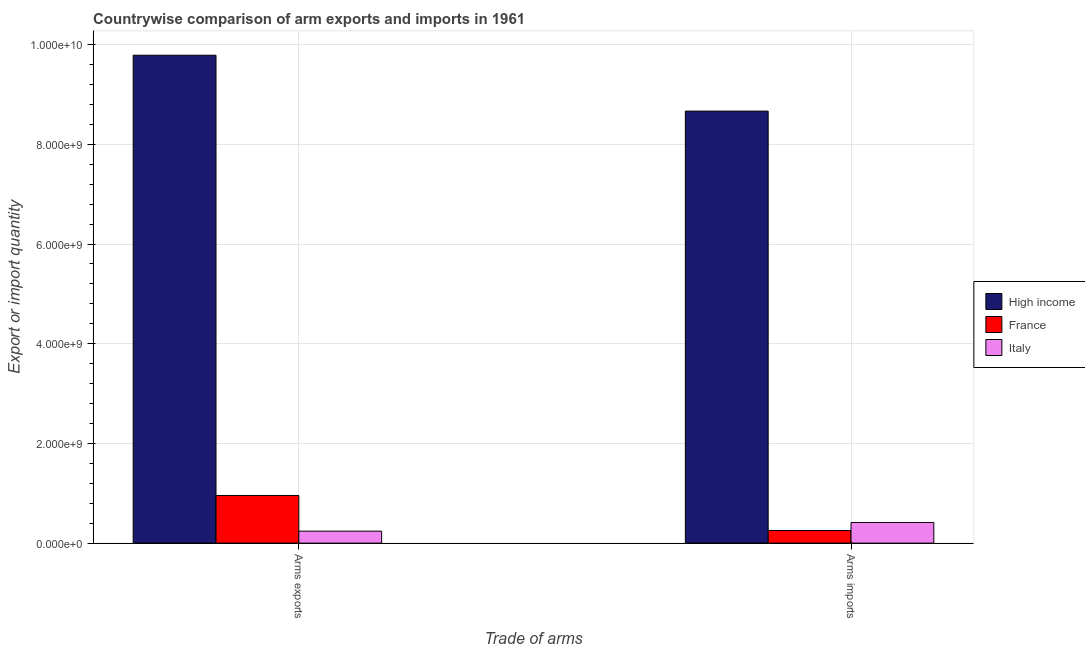How many different coloured bars are there?
Provide a short and direct response. 3. How many groups of bars are there?
Your response must be concise. 2. Are the number of bars per tick equal to the number of legend labels?
Provide a succinct answer. Yes. How many bars are there on the 2nd tick from the left?
Offer a terse response. 3. How many bars are there on the 1st tick from the right?
Give a very brief answer. 3. What is the label of the 2nd group of bars from the left?
Offer a very short reply. Arms imports. What is the arms exports in High income?
Make the answer very short. 9.79e+09. Across all countries, what is the maximum arms exports?
Your answer should be compact. 9.79e+09. Across all countries, what is the minimum arms imports?
Give a very brief answer. 2.53e+08. In which country was the arms exports maximum?
Give a very brief answer. High income. What is the total arms exports in the graph?
Your answer should be very brief. 1.10e+1. What is the difference between the arms exports in High income and that in Italy?
Provide a succinct answer. 9.55e+09. What is the difference between the arms exports in High income and the arms imports in Italy?
Ensure brevity in your answer.  9.37e+09. What is the average arms imports per country?
Offer a terse response. 3.11e+09. What is the difference between the arms imports and arms exports in Italy?
Provide a short and direct response. 1.74e+08. In how many countries, is the arms imports greater than 6400000000 ?
Offer a terse response. 1. What is the ratio of the arms exports in Italy to that in High income?
Give a very brief answer. 0.02. Is the arms imports in Italy less than that in High income?
Your answer should be compact. Yes. What does the 1st bar from the left in Arms exports represents?
Your answer should be compact. High income. What does the 2nd bar from the right in Arms imports represents?
Your answer should be compact. France. Are all the bars in the graph horizontal?
Ensure brevity in your answer.  No. How many countries are there in the graph?
Make the answer very short. 3. What is the difference between two consecutive major ticks on the Y-axis?
Your answer should be very brief. 2.00e+09. Does the graph contain grids?
Keep it short and to the point. Yes. What is the title of the graph?
Give a very brief answer. Countrywise comparison of arm exports and imports in 1961. Does "Bosnia and Herzegovina" appear as one of the legend labels in the graph?
Your response must be concise. No. What is the label or title of the X-axis?
Your response must be concise. Trade of arms. What is the label or title of the Y-axis?
Your answer should be very brief. Export or import quantity. What is the Export or import quantity in High income in Arms exports?
Offer a terse response. 9.79e+09. What is the Export or import quantity in France in Arms exports?
Make the answer very short. 9.56e+08. What is the Export or import quantity in Italy in Arms exports?
Your answer should be compact. 2.40e+08. What is the Export or import quantity in High income in Arms imports?
Your response must be concise. 8.67e+09. What is the Export or import quantity in France in Arms imports?
Your answer should be compact. 2.53e+08. What is the Export or import quantity in Italy in Arms imports?
Make the answer very short. 4.14e+08. Across all Trade of arms, what is the maximum Export or import quantity of High income?
Your answer should be compact. 9.79e+09. Across all Trade of arms, what is the maximum Export or import quantity of France?
Ensure brevity in your answer.  9.56e+08. Across all Trade of arms, what is the maximum Export or import quantity in Italy?
Your answer should be compact. 4.14e+08. Across all Trade of arms, what is the minimum Export or import quantity of High income?
Your answer should be compact. 8.67e+09. Across all Trade of arms, what is the minimum Export or import quantity of France?
Provide a succinct answer. 2.53e+08. Across all Trade of arms, what is the minimum Export or import quantity of Italy?
Keep it short and to the point. 2.40e+08. What is the total Export or import quantity in High income in the graph?
Your answer should be very brief. 1.85e+1. What is the total Export or import quantity of France in the graph?
Offer a terse response. 1.21e+09. What is the total Export or import quantity in Italy in the graph?
Offer a very short reply. 6.54e+08. What is the difference between the Export or import quantity of High income in Arms exports and that in Arms imports?
Your answer should be very brief. 1.12e+09. What is the difference between the Export or import quantity in France in Arms exports and that in Arms imports?
Offer a very short reply. 7.03e+08. What is the difference between the Export or import quantity in Italy in Arms exports and that in Arms imports?
Your response must be concise. -1.74e+08. What is the difference between the Export or import quantity in High income in Arms exports and the Export or import quantity in France in Arms imports?
Your answer should be very brief. 9.54e+09. What is the difference between the Export or import quantity of High income in Arms exports and the Export or import quantity of Italy in Arms imports?
Your answer should be very brief. 9.37e+09. What is the difference between the Export or import quantity of France in Arms exports and the Export or import quantity of Italy in Arms imports?
Provide a short and direct response. 5.42e+08. What is the average Export or import quantity of High income per Trade of arms?
Provide a succinct answer. 9.23e+09. What is the average Export or import quantity in France per Trade of arms?
Provide a short and direct response. 6.04e+08. What is the average Export or import quantity of Italy per Trade of arms?
Ensure brevity in your answer.  3.27e+08. What is the difference between the Export or import quantity of High income and Export or import quantity of France in Arms exports?
Ensure brevity in your answer.  8.83e+09. What is the difference between the Export or import quantity in High income and Export or import quantity in Italy in Arms exports?
Give a very brief answer. 9.55e+09. What is the difference between the Export or import quantity in France and Export or import quantity in Italy in Arms exports?
Keep it short and to the point. 7.16e+08. What is the difference between the Export or import quantity in High income and Export or import quantity in France in Arms imports?
Your answer should be very brief. 8.41e+09. What is the difference between the Export or import quantity in High income and Export or import quantity in Italy in Arms imports?
Your answer should be compact. 8.25e+09. What is the difference between the Export or import quantity in France and Export or import quantity in Italy in Arms imports?
Keep it short and to the point. -1.61e+08. What is the ratio of the Export or import quantity in High income in Arms exports to that in Arms imports?
Give a very brief answer. 1.13. What is the ratio of the Export or import quantity of France in Arms exports to that in Arms imports?
Provide a short and direct response. 3.78. What is the ratio of the Export or import quantity of Italy in Arms exports to that in Arms imports?
Make the answer very short. 0.58. What is the difference between the highest and the second highest Export or import quantity of High income?
Your answer should be very brief. 1.12e+09. What is the difference between the highest and the second highest Export or import quantity in France?
Keep it short and to the point. 7.03e+08. What is the difference between the highest and the second highest Export or import quantity of Italy?
Your response must be concise. 1.74e+08. What is the difference between the highest and the lowest Export or import quantity of High income?
Make the answer very short. 1.12e+09. What is the difference between the highest and the lowest Export or import quantity in France?
Keep it short and to the point. 7.03e+08. What is the difference between the highest and the lowest Export or import quantity of Italy?
Your answer should be compact. 1.74e+08. 